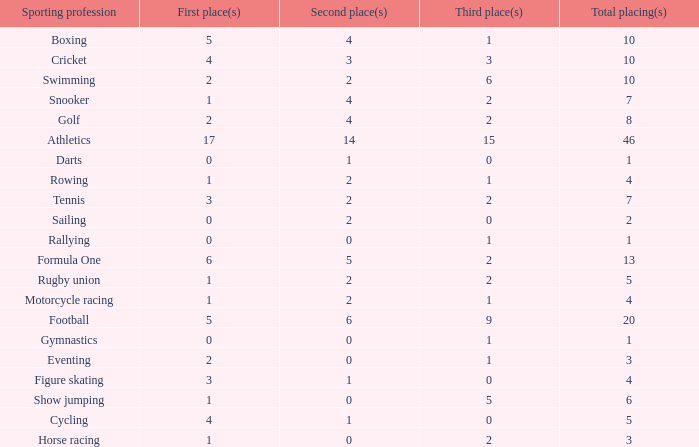What is the total number of 3rd place entries that have exactly 8 total placings? 1.0. 